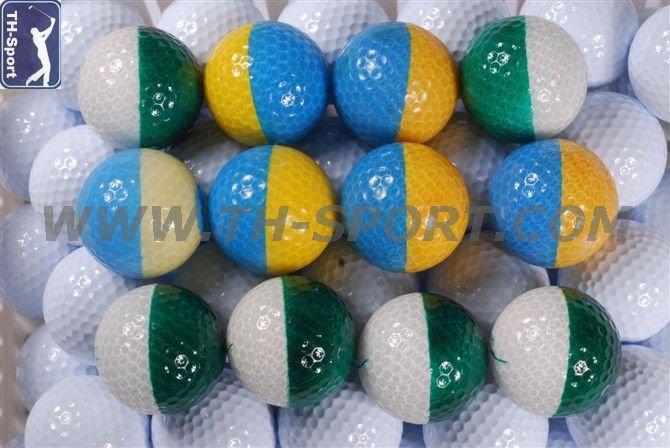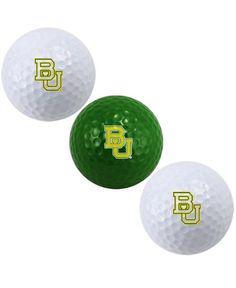The first image is the image on the left, the second image is the image on the right. For the images shown, is this caption "There are exactly two golf balls painted with half of one color and half of another color." true? Answer yes or no. No. The first image is the image on the left, the second image is the image on the right. Evaluate the accuracy of this statement regarding the images: "Atleast one image has a pure white ball". Is it true? Answer yes or no. Yes. 